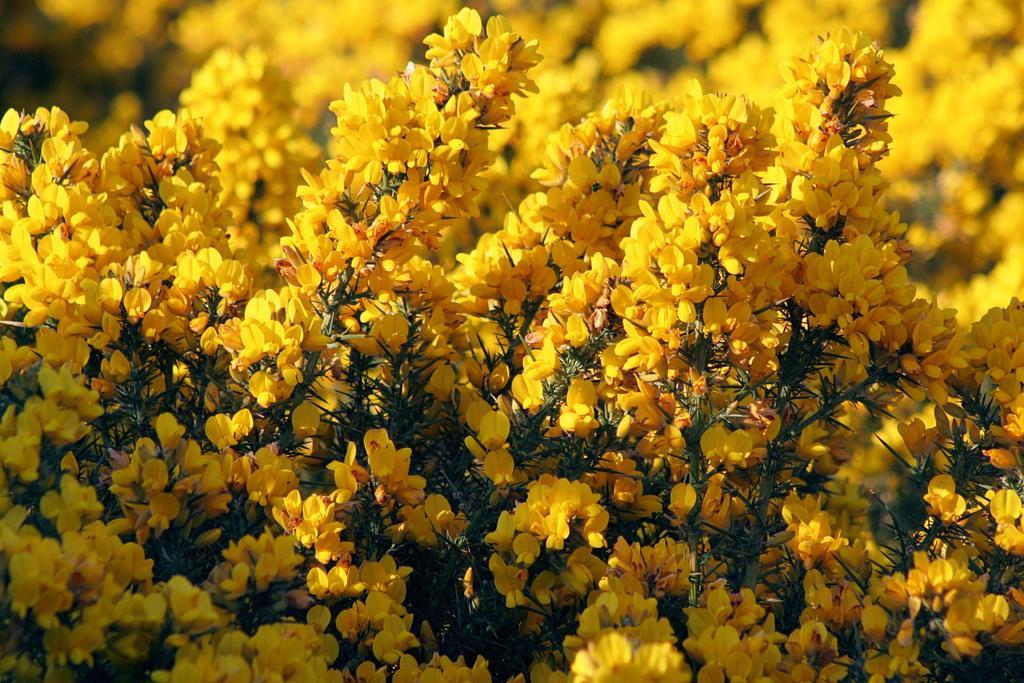Can you describe this image briefly? In this image we can see many plants. There are many flowers to the plants. 